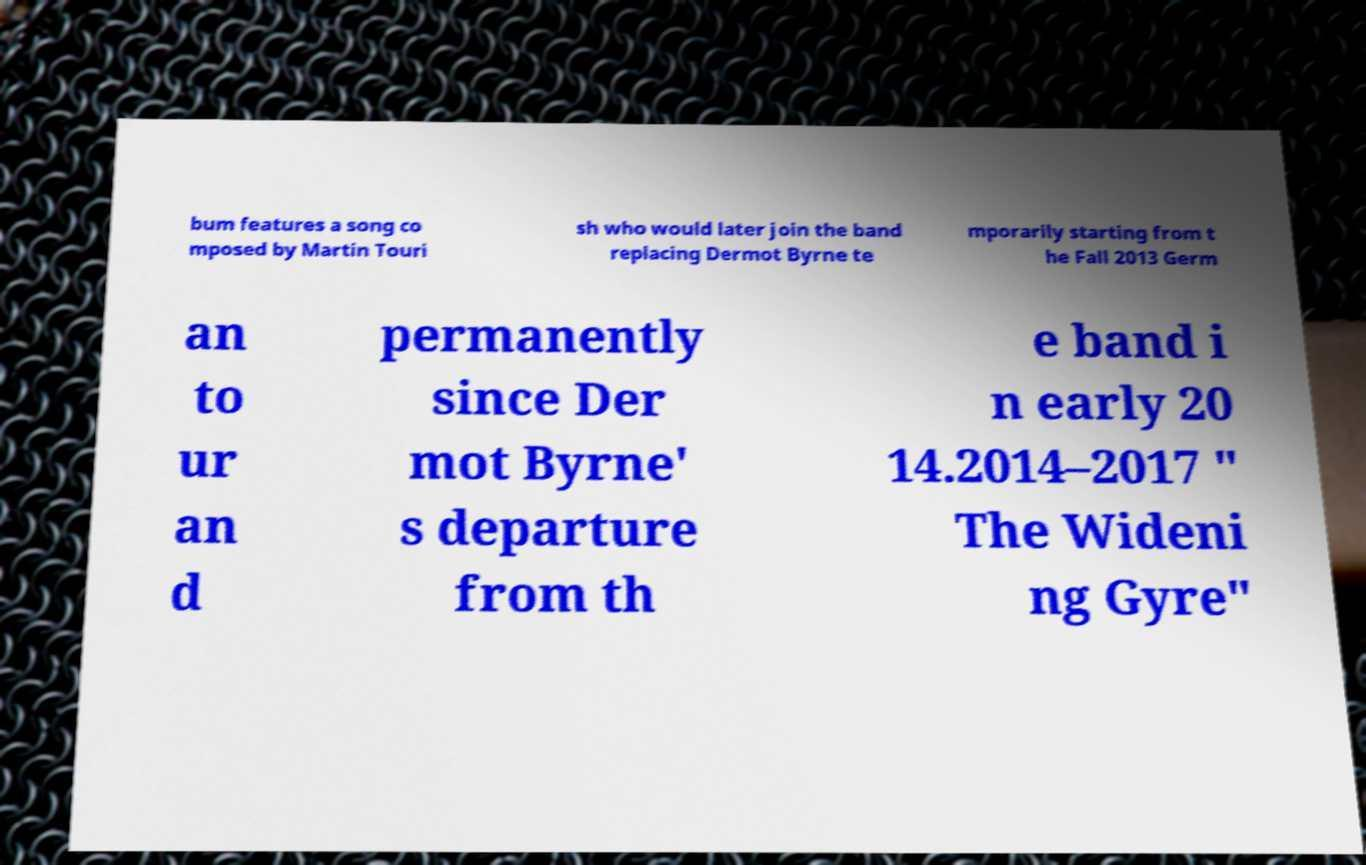For documentation purposes, I need the text within this image transcribed. Could you provide that? bum features a song co mposed by Martin Touri sh who would later join the band replacing Dermot Byrne te mporarily starting from t he Fall 2013 Germ an to ur an d permanently since Der mot Byrne' s departure from th e band i n early 20 14.2014–2017 " The Wideni ng Gyre" 